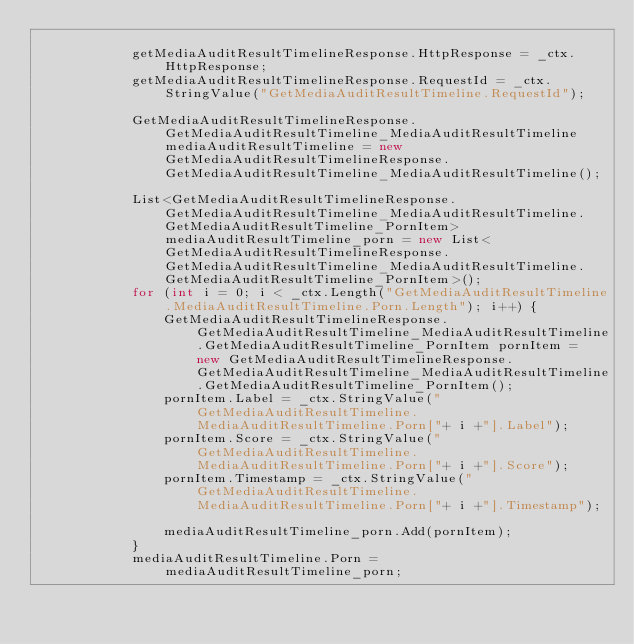<code> <loc_0><loc_0><loc_500><loc_500><_C#_>
			getMediaAuditResultTimelineResponse.HttpResponse = _ctx.HttpResponse;
			getMediaAuditResultTimelineResponse.RequestId = _ctx.StringValue("GetMediaAuditResultTimeline.RequestId");

			GetMediaAuditResultTimelineResponse.GetMediaAuditResultTimeline_MediaAuditResultTimeline mediaAuditResultTimeline = new GetMediaAuditResultTimelineResponse.GetMediaAuditResultTimeline_MediaAuditResultTimeline();

			List<GetMediaAuditResultTimelineResponse.GetMediaAuditResultTimeline_MediaAuditResultTimeline.GetMediaAuditResultTimeline_PornItem> mediaAuditResultTimeline_porn = new List<GetMediaAuditResultTimelineResponse.GetMediaAuditResultTimeline_MediaAuditResultTimeline.GetMediaAuditResultTimeline_PornItem>();
			for (int i = 0; i < _ctx.Length("GetMediaAuditResultTimeline.MediaAuditResultTimeline.Porn.Length"); i++) {
				GetMediaAuditResultTimelineResponse.GetMediaAuditResultTimeline_MediaAuditResultTimeline.GetMediaAuditResultTimeline_PornItem pornItem = new GetMediaAuditResultTimelineResponse.GetMediaAuditResultTimeline_MediaAuditResultTimeline.GetMediaAuditResultTimeline_PornItem();
				pornItem.Label = _ctx.StringValue("GetMediaAuditResultTimeline.MediaAuditResultTimeline.Porn["+ i +"].Label");
				pornItem.Score = _ctx.StringValue("GetMediaAuditResultTimeline.MediaAuditResultTimeline.Porn["+ i +"].Score");
				pornItem.Timestamp = _ctx.StringValue("GetMediaAuditResultTimeline.MediaAuditResultTimeline.Porn["+ i +"].Timestamp");

				mediaAuditResultTimeline_porn.Add(pornItem);
			}
			mediaAuditResultTimeline.Porn = mediaAuditResultTimeline_porn;
</code> 